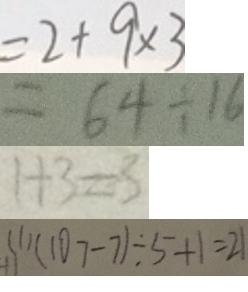Convert formula to latex. <formula><loc_0><loc_0><loc_500><loc_500>= 2 + 9 \times 3 
 = 6 4 \div 1 6 
 1 + 3 = 3 
 ( 1 ) ( 1 0 7 - 7 ) \div 5 + 1 = 2 1</formula> 